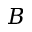<formula> <loc_0><loc_0><loc_500><loc_500>B</formula> 